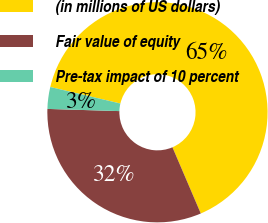Convert chart. <chart><loc_0><loc_0><loc_500><loc_500><pie_chart><fcel>(in millions of US dollars)<fcel>Fair value of equity<fcel>Pre-tax impact of 10 percent<nl><fcel>64.88%<fcel>31.92%<fcel>3.2%<nl></chart> 